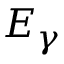<formula> <loc_0><loc_0><loc_500><loc_500>E _ { \gamma }</formula> 